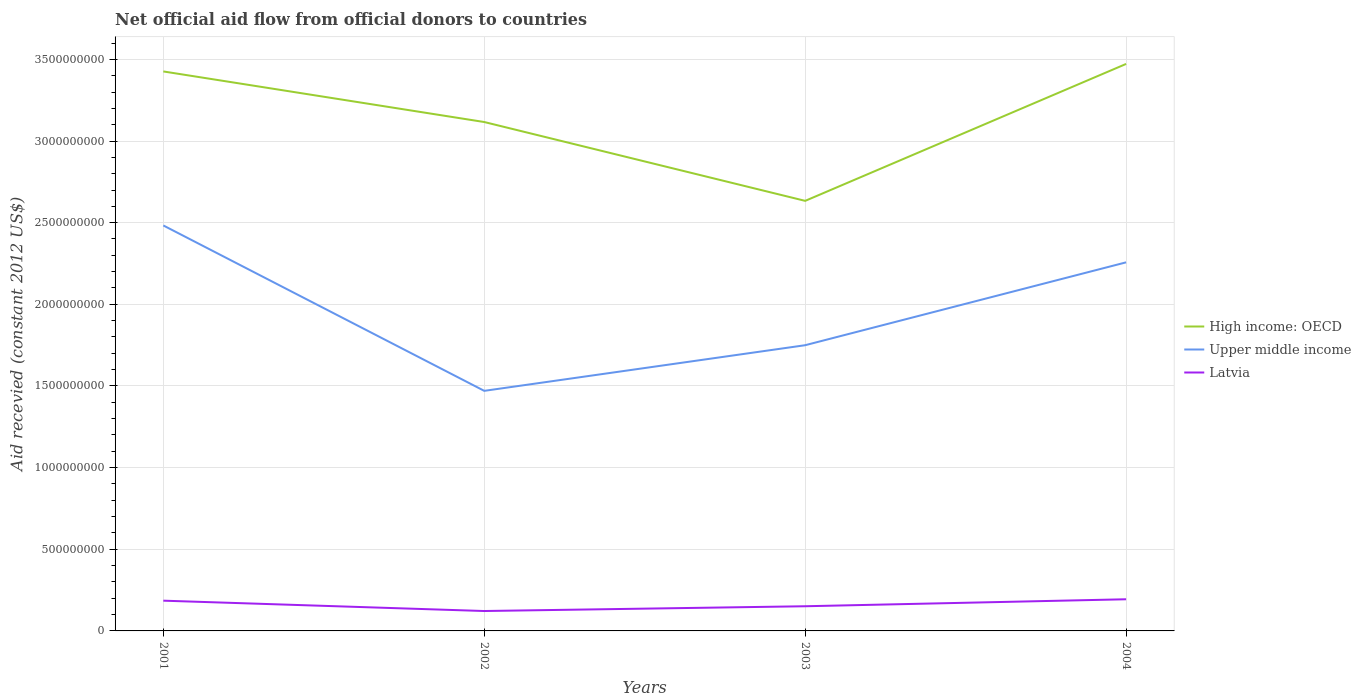How many different coloured lines are there?
Your answer should be compact. 3. Across all years, what is the maximum total aid received in High income: OECD?
Offer a very short reply. 2.63e+09. What is the total total aid received in Upper middle income in the graph?
Provide a succinct answer. 2.26e+08. What is the difference between the highest and the second highest total aid received in Latvia?
Your response must be concise. 7.20e+07. How many lines are there?
Make the answer very short. 3. How many years are there in the graph?
Your answer should be very brief. 4. Are the values on the major ticks of Y-axis written in scientific E-notation?
Offer a terse response. No. Where does the legend appear in the graph?
Ensure brevity in your answer.  Center right. How many legend labels are there?
Offer a terse response. 3. What is the title of the graph?
Your answer should be very brief. Net official aid flow from official donors to countries. Does "Curacao" appear as one of the legend labels in the graph?
Your answer should be compact. No. What is the label or title of the Y-axis?
Give a very brief answer. Aid recevied (constant 2012 US$). What is the Aid recevied (constant 2012 US$) in High income: OECD in 2001?
Make the answer very short. 3.43e+09. What is the Aid recevied (constant 2012 US$) in Upper middle income in 2001?
Offer a very short reply. 2.48e+09. What is the Aid recevied (constant 2012 US$) of Latvia in 2001?
Keep it short and to the point. 1.85e+08. What is the Aid recevied (constant 2012 US$) in High income: OECD in 2002?
Offer a very short reply. 3.12e+09. What is the Aid recevied (constant 2012 US$) in Upper middle income in 2002?
Make the answer very short. 1.47e+09. What is the Aid recevied (constant 2012 US$) of Latvia in 2002?
Your answer should be very brief. 1.22e+08. What is the Aid recevied (constant 2012 US$) in High income: OECD in 2003?
Offer a terse response. 2.63e+09. What is the Aid recevied (constant 2012 US$) of Upper middle income in 2003?
Give a very brief answer. 1.75e+09. What is the Aid recevied (constant 2012 US$) of Latvia in 2003?
Offer a very short reply. 1.51e+08. What is the Aid recevied (constant 2012 US$) of High income: OECD in 2004?
Offer a terse response. 3.47e+09. What is the Aid recevied (constant 2012 US$) in Upper middle income in 2004?
Provide a succinct answer. 2.26e+09. What is the Aid recevied (constant 2012 US$) in Latvia in 2004?
Your answer should be compact. 1.94e+08. Across all years, what is the maximum Aid recevied (constant 2012 US$) in High income: OECD?
Make the answer very short. 3.47e+09. Across all years, what is the maximum Aid recevied (constant 2012 US$) of Upper middle income?
Ensure brevity in your answer.  2.48e+09. Across all years, what is the maximum Aid recevied (constant 2012 US$) in Latvia?
Your answer should be very brief. 1.94e+08. Across all years, what is the minimum Aid recevied (constant 2012 US$) of High income: OECD?
Provide a short and direct response. 2.63e+09. Across all years, what is the minimum Aid recevied (constant 2012 US$) in Upper middle income?
Your response must be concise. 1.47e+09. Across all years, what is the minimum Aid recevied (constant 2012 US$) of Latvia?
Offer a terse response. 1.22e+08. What is the total Aid recevied (constant 2012 US$) in High income: OECD in the graph?
Your answer should be very brief. 1.26e+1. What is the total Aid recevied (constant 2012 US$) in Upper middle income in the graph?
Provide a short and direct response. 7.96e+09. What is the total Aid recevied (constant 2012 US$) in Latvia in the graph?
Your response must be concise. 6.52e+08. What is the difference between the Aid recevied (constant 2012 US$) of High income: OECD in 2001 and that in 2002?
Make the answer very short. 3.10e+08. What is the difference between the Aid recevied (constant 2012 US$) in Upper middle income in 2001 and that in 2002?
Ensure brevity in your answer.  1.01e+09. What is the difference between the Aid recevied (constant 2012 US$) in Latvia in 2001 and that in 2002?
Provide a succinct answer. 6.34e+07. What is the difference between the Aid recevied (constant 2012 US$) in High income: OECD in 2001 and that in 2003?
Provide a short and direct response. 7.93e+08. What is the difference between the Aid recevied (constant 2012 US$) in Upper middle income in 2001 and that in 2003?
Give a very brief answer. 7.33e+08. What is the difference between the Aid recevied (constant 2012 US$) in Latvia in 2001 and that in 2003?
Offer a very short reply. 3.42e+07. What is the difference between the Aid recevied (constant 2012 US$) in High income: OECD in 2001 and that in 2004?
Your answer should be compact. -4.60e+07. What is the difference between the Aid recevied (constant 2012 US$) in Upper middle income in 2001 and that in 2004?
Keep it short and to the point. 2.26e+08. What is the difference between the Aid recevied (constant 2012 US$) in Latvia in 2001 and that in 2004?
Provide a short and direct response. -8.60e+06. What is the difference between the Aid recevied (constant 2012 US$) of High income: OECD in 2002 and that in 2003?
Make the answer very short. 4.83e+08. What is the difference between the Aid recevied (constant 2012 US$) of Upper middle income in 2002 and that in 2003?
Ensure brevity in your answer.  -2.79e+08. What is the difference between the Aid recevied (constant 2012 US$) of Latvia in 2002 and that in 2003?
Provide a short and direct response. -2.92e+07. What is the difference between the Aid recevied (constant 2012 US$) in High income: OECD in 2002 and that in 2004?
Keep it short and to the point. -3.56e+08. What is the difference between the Aid recevied (constant 2012 US$) of Upper middle income in 2002 and that in 2004?
Give a very brief answer. -7.87e+08. What is the difference between the Aid recevied (constant 2012 US$) in Latvia in 2002 and that in 2004?
Your answer should be very brief. -7.20e+07. What is the difference between the Aid recevied (constant 2012 US$) of High income: OECD in 2003 and that in 2004?
Your answer should be very brief. -8.39e+08. What is the difference between the Aid recevied (constant 2012 US$) of Upper middle income in 2003 and that in 2004?
Give a very brief answer. -5.07e+08. What is the difference between the Aid recevied (constant 2012 US$) of Latvia in 2003 and that in 2004?
Offer a terse response. -4.28e+07. What is the difference between the Aid recevied (constant 2012 US$) of High income: OECD in 2001 and the Aid recevied (constant 2012 US$) of Upper middle income in 2002?
Provide a succinct answer. 1.96e+09. What is the difference between the Aid recevied (constant 2012 US$) of High income: OECD in 2001 and the Aid recevied (constant 2012 US$) of Latvia in 2002?
Provide a short and direct response. 3.30e+09. What is the difference between the Aid recevied (constant 2012 US$) in Upper middle income in 2001 and the Aid recevied (constant 2012 US$) in Latvia in 2002?
Ensure brevity in your answer.  2.36e+09. What is the difference between the Aid recevied (constant 2012 US$) in High income: OECD in 2001 and the Aid recevied (constant 2012 US$) in Upper middle income in 2003?
Ensure brevity in your answer.  1.68e+09. What is the difference between the Aid recevied (constant 2012 US$) in High income: OECD in 2001 and the Aid recevied (constant 2012 US$) in Latvia in 2003?
Your answer should be very brief. 3.28e+09. What is the difference between the Aid recevied (constant 2012 US$) in Upper middle income in 2001 and the Aid recevied (constant 2012 US$) in Latvia in 2003?
Give a very brief answer. 2.33e+09. What is the difference between the Aid recevied (constant 2012 US$) of High income: OECD in 2001 and the Aid recevied (constant 2012 US$) of Upper middle income in 2004?
Offer a terse response. 1.17e+09. What is the difference between the Aid recevied (constant 2012 US$) in High income: OECD in 2001 and the Aid recevied (constant 2012 US$) in Latvia in 2004?
Your answer should be very brief. 3.23e+09. What is the difference between the Aid recevied (constant 2012 US$) of Upper middle income in 2001 and the Aid recevied (constant 2012 US$) of Latvia in 2004?
Offer a very short reply. 2.29e+09. What is the difference between the Aid recevied (constant 2012 US$) of High income: OECD in 2002 and the Aid recevied (constant 2012 US$) of Upper middle income in 2003?
Offer a very short reply. 1.37e+09. What is the difference between the Aid recevied (constant 2012 US$) in High income: OECD in 2002 and the Aid recevied (constant 2012 US$) in Latvia in 2003?
Your answer should be very brief. 2.97e+09. What is the difference between the Aid recevied (constant 2012 US$) in Upper middle income in 2002 and the Aid recevied (constant 2012 US$) in Latvia in 2003?
Provide a succinct answer. 1.32e+09. What is the difference between the Aid recevied (constant 2012 US$) of High income: OECD in 2002 and the Aid recevied (constant 2012 US$) of Upper middle income in 2004?
Ensure brevity in your answer.  8.59e+08. What is the difference between the Aid recevied (constant 2012 US$) in High income: OECD in 2002 and the Aid recevied (constant 2012 US$) in Latvia in 2004?
Provide a succinct answer. 2.92e+09. What is the difference between the Aid recevied (constant 2012 US$) in Upper middle income in 2002 and the Aid recevied (constant 2012 US$) in Latvia in 2004?
Give a very brief answer. 1.28e+09. What is the difference between the Aid recevied (constant 2012 US$) of High income: OECD in 2003 and the Aid recevied (constant 2012 US$) of Upper middle income in 2004?
Offer a very short reply. 3.77e+08. What is the difference between the Aid recevied (constant 2012 US$) in High income: OECD in 2003 and the Aid recevied (constant 2012 US$) in Latvia in 2004?
Provide a succinct answer. 2.44e+09. What is the difference between the Aid recevied (constant 2012 US$) of Upper middle income in 2003 and the Aid recevied (constant 2012 US$) of Latvia in 2004?
Your answer should be very brief. 1.56e+09. What is the average Aid recevied (constant 2012 US$) of High income: OECD per year?
Your answer should be compact. 3.16e+09. What is the average Aid recevied (constant 2012 US$) in Upper middle income per year?
Make the answer very short. 1.99e+09. What is the average Aid recevied (constant 2012 US$) of Latvia per year?
Offer a very short reply. 1.63e+08. In the year 2001, what is the difference between the Aid recevied (constant 2012 US$) of High income: OECD and Aid recevied (constant 2012 US$) of Upper middle income?
Make the answer very short. 9.43e+08. In the year 2001, what is the difference between the Aid recevied (constant 2012 US$) in High income: OECD and Aid recevied (constant 2012 US$) in Latvia?
Provide a succinct answer. 3.24e+09. In the year 2001, what is the difference between the Aid recevied (constant 2012 US$) in Upper middle income and Aid recevied (constant 2012 US$) in Latvia?
Ensure brevity in your answer.  2.30e+09. In the year 2002, what is the difference between the Aid recevied (constant 2012 US$) of High income: OECD and Aid recevied (constant 2012 US$) of Upper middle income?
Your answer should be very brief. 1.65e+09. In the year 2002, what is the difference between the Aid recevied (constant 2012 US$) in High income: OECD and Aid recevied (constant 2012 US$) in Latvia?
Provide a short and direct response. 2.99e+09. In the year 2002, what is the difference between the Aid recevied (constant 2012 US$) of Upper middle income and Aid recevied (constant 2012 US$) of Latvia?
Give a very brief answer. 1.35e+09. In the year 2003, what is the difference between the Aid recevied (constant 2012 US$) of High income: OECD and Aid recevied (constant 2012 US$) of Upper middle income?
Offer a very short reply. 8.84e+08. In the year 2003, what is the difference between the Aid recevied (constant 2012 US$) of High income: OECD and Aid recevied (constant 2012 US$) of Latvia?
Keep it short and to the point. 2.48e+09. In the year 2003, what is the difference between the Aid recevied (constant 2012 US$) of Upper middle income and Aid recevied (constant 2012 US$) of Latvia?
Your response must be concise. 1.60e+09. In the year 2004, what is the difference between the Aid recevied (constant 2012 US$) in High income: OECD and Aid recevied (constant 2012 US$) in Upper middle income?
Provide a short and direct response. 1.22e+09. In the year 2004, what is the difference between the Aid recevied (constant 2012 US$) of High income: OECD and Aid recevied (constant 2012 US$) of Latvia?
Provide a short and direct response. 3.28e+09. In the year 2004, what is the difference between the Aid recevied (constant 2012 US$) in Upper middle income and Aid recevied (constant 2012 US$) in Latvia?
Give a very brief answer. 2.06e+09. What is the ratio of the Aid recevied (constant 2012 US$) of High income: OECD in 2001 to that in 2002?
Make the answer very short. 1.1. What is the ratio of the Aid recevied (constant 2012 US$) of Upper middle income in 2001 to that in 2002?
Provide a short and direct response. 1.69. What is the ratio of the Aid recevied (constant 2012 US$) of Latvia in 2001 to that in 2002?
Provide a succinct answer. 1.52. What is the ratio of the Aid recevied (constant 2012 US$) in High income: OECD in 2001 to that in 2003?
Provide a succinct answer. 1.3. What is the ratio of the Aid recevied (constant 2012 US$) of Upper middle income in 2001 to that in 2003?
Your answer should be compact. 1.42. What is the ratio of the Aid recevied (constant 2012 US$) of Latvia in 2001 to that in 2003?
Give a very brief answer. 1.23. What is the ratio of the Aid recevied (constant 2012 US$) of Upper middle income in 2001 to that in 2004?
Ensure brevity in your answer.  1.1. What is the ratio of the Aid recevied (constant 2012 US$) in Latvia in 2001 to that in 2004?
Ensure brevity in your answer.  0.96. What is the ratio of the Aid recevied (constant 2012 US$) of High income: OECD in 2002 to that in 2003?
Provide a short and direct response. 1.18. What is the ratio of the Aid recevied (constant 2012 US$) in Upper middle income in 2002 to that in 2003?
Offer a very short reply. 0.84. What is the ratio of the Aid recevied (constant 2012 US$) of Latvia in 2002 to that in 2003?
Provide a short and direct response. 0.81. What is the ratio of the Aid recevied (constant 2012 US$) of High income: OECD in 2002 to that in 2004?
Offer a very short reply. 0.9. What is the ratio of the Aid recevied (constant 2012 US$) of Upper middle income in 2002 to that in 2004?
Provide a short and direct response. 0.65. What is the ratio of the Aid recevied (constant 2012 US$) in Latvia in 2002 to that in 2004?
Your response must be concise. 0.63. What is the ratio of the Aid recevied (constant 2012 US$) of High income: OECD in 2003 to that in 2004?
Your answer should be compact. 0.76. What is the ratio of the Aid recevied (constant 2012 US$) in Upper middle income in 2003 to that in 2004?
Offer a terse response. 0.78. What is the ratio of the Aid recevied (constant 2012 US$) of Latvia in 2003 to that in 2004?
Ensure brevity in your answer.  0.78. What is the difference between the highest and the second highest Aid recevied (constant 2012 US$) of High income: OECD?
Give a very brief answer. 4.60e+07. What is the difference between the highest and the second highest Aid recevied (constant 2012 US$) in Upper middle income?
Offer a very short reply. 2.26e+08. What is the difference between the highest and the second highest Aid recevied (constant 2012 US$) in Latvia?
Your answer should be compact. 8.60e+06. What is the difference between the highest and the lowest Aid recevied (constant 2012 US$) of High income: OECD?
Provide a succinct answer. 8.39e+08. What is the difference between the highest and the lowest Aid recevied (constant 2012 US$) in Upper middle income?
Your answer should be compact. 1.01e+09. What is the difference between the highest and the lowest Aid recevied (constant 2012 US$) of Latvia?
Give a very brief answer. 7.20e+07. 